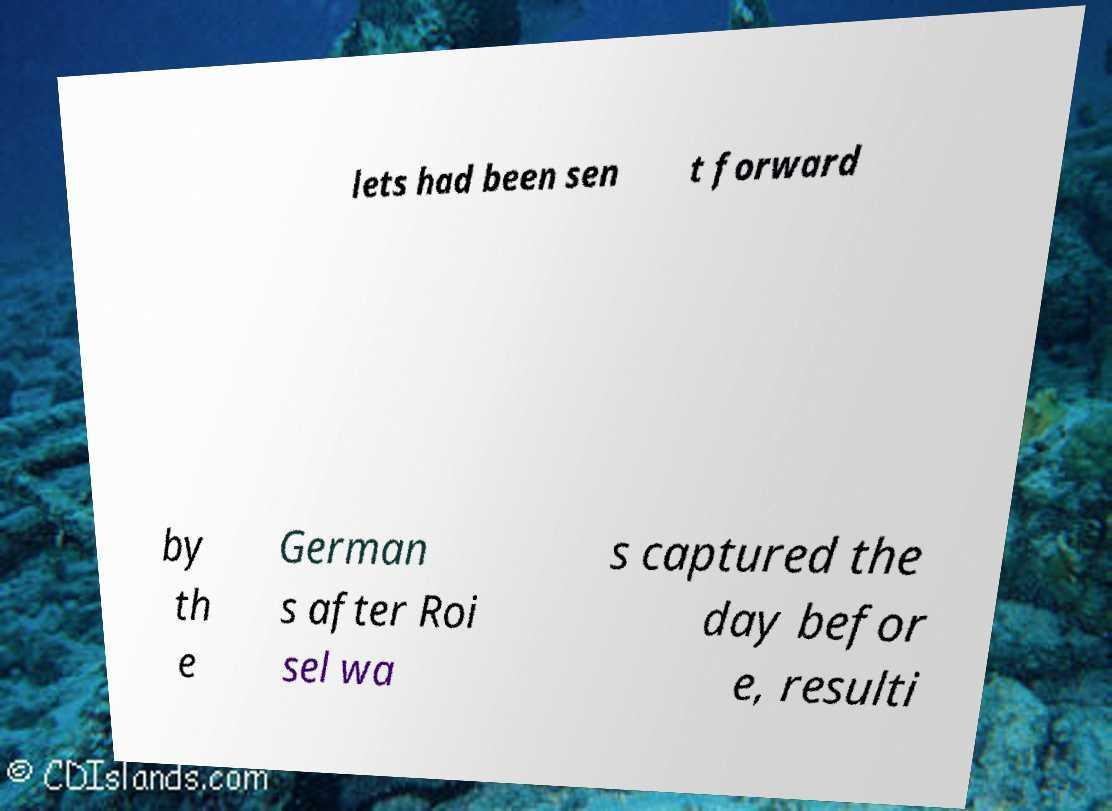Could you extract and type out the text from this image? lets had been sen t forward by th e German s after Roi sel wa s captured the day befor e, resulti 